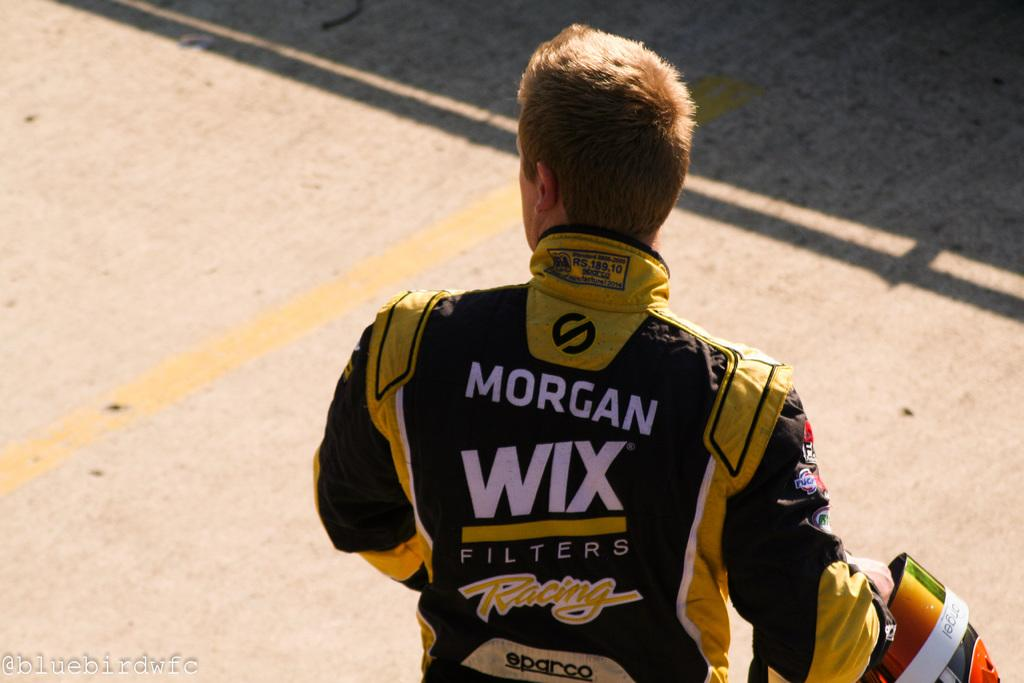What is the man in the image doing? The man is standing in the image. What object is the man holding in his hand? The man is holding a helmet in his hand. What can be seen on the road in the image? There is a yellow line on the road in the image. What type of cactus can be seen in the background of the image? There is no cactus present in the image; it features a man standing with a helmet in his hand and a yellow line on the road. 